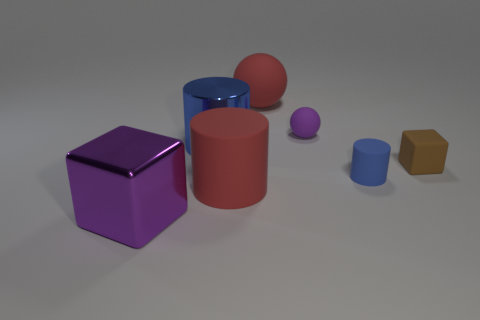Subtract all cyan cubes. How many blue cylinders are left? 2 Subtract all matte cylinders. How many cylinders are left? 1 Add 2 small purple rubber balls. How many objects exist? 9 Subtract all purple cylinders. Subtract all brown balls. How many cylinders are left? 3 Add 1 large red rubber things. How many large red rubber things exist? 3 Subtract 0 brown cylinders. How many objects are left? 7 Subtract all cylinders. How many objects are left? 4 Subtract all small green shiny objects. Subtract all large purple objects. How many objects are left? 6 Add 3 tiny blue rubber cylinders. How many tiny blue rubber cylinders are left? 4 